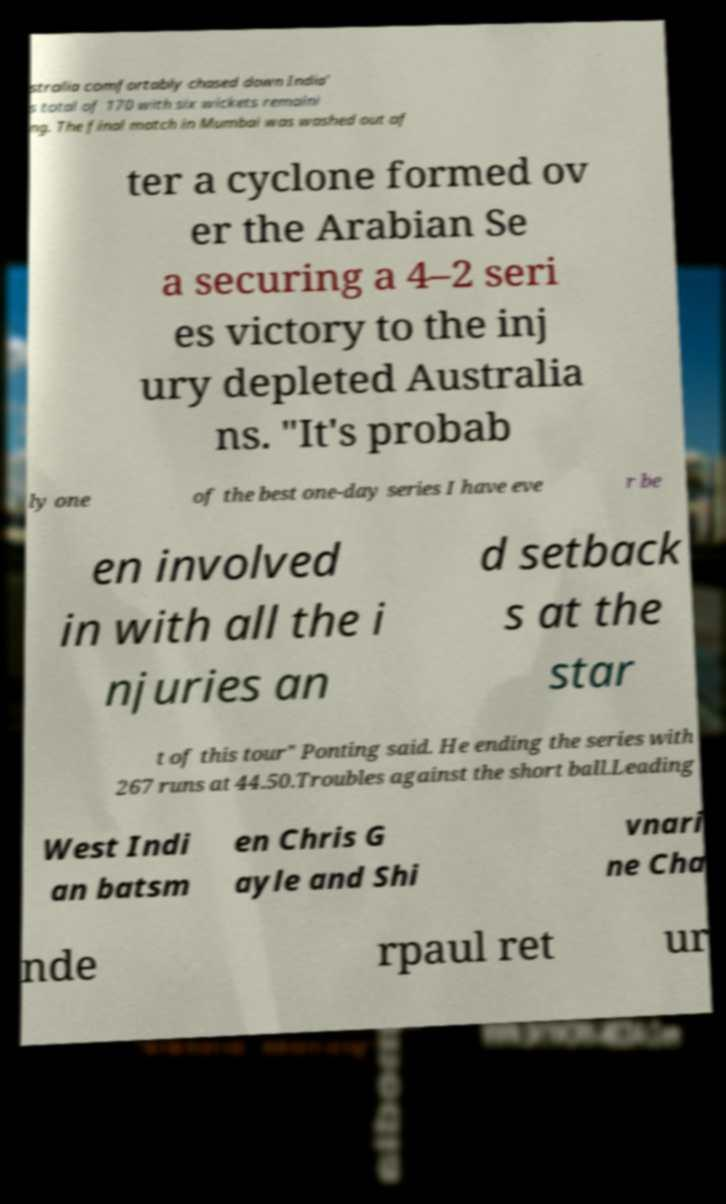Please read and relay the text visible in this image. What does it say? stralia comfortably chased down India' s total of 170 with six wickets remaini ng. The final match in Mumbai was washed out af ter a cyclone formed ov er the Arabian Se a securing a 4–2 seri es victory to the inj ury depleted Australia ns. "It's probab ly one of the best one-day series I have eve r be en involved in with all the i njuries an d setback s at the star t of this tour" Ponting said. He ending the series with 267 runs at 44.50.Troubles against the short ball.Leading West Indi an batsm en Chris G ayle and Shi vnari ne Cha nde rpaul ret ur 